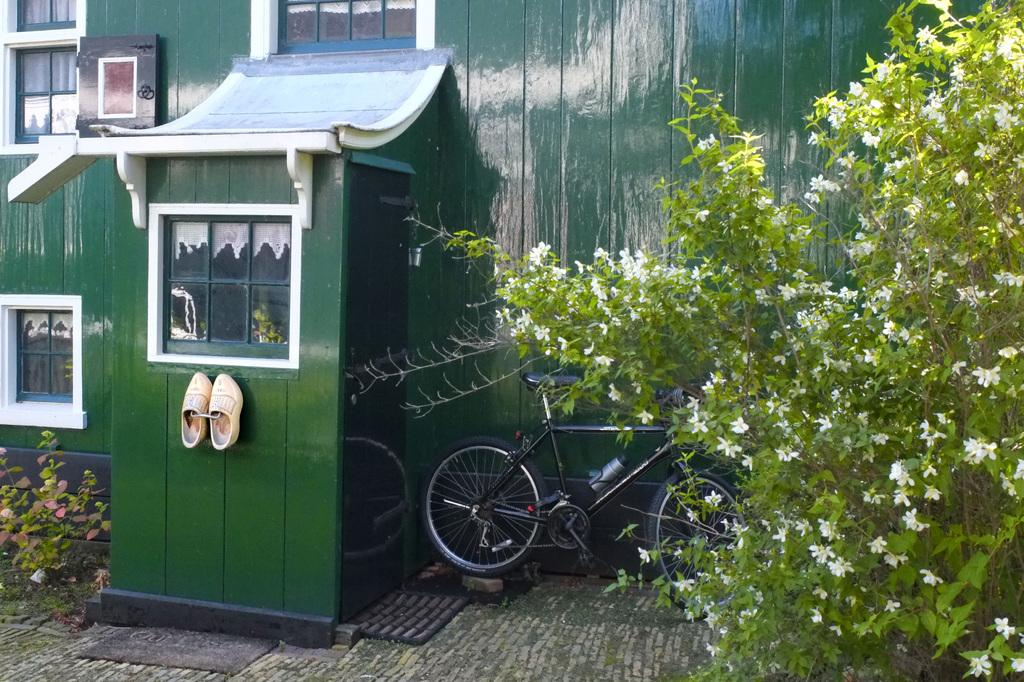What type of structure is visible in the image? There is a building with windows in the image. What is hanging on the hanger in the image? Shoes are present on a hanger. What mode of transportation can be seen in the image? A bicycle is parked in the image. What type of vegetation is present in the image? There are plants in the image. What type of flowers can be seen in the image? Flowers are visible in the image. What type of whistle can be heard in the image? There is no whistle present or audible in the image. What type of pleasure can be seen in the image? The image does not depict any specific pleasure or emotion; it is a still image of various objects and items. 